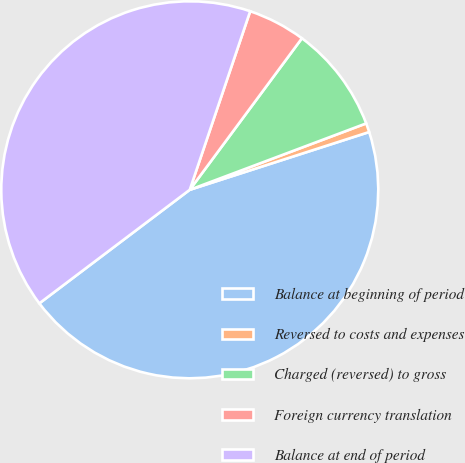<chart> <loc_0><loc_0><loc_500><loc_500><pie_chart><fcel>Balance at beginning of period<fcel>Reversed to costs and expenses<fcel>Charged (reversed) to gross<fcel>Foreign currency translation<fcel>Balance at end of period<nl><fcel>44.67%<fcel>0.77%<fcel>9.13%<fcel>4.95%<fcel>40.49%<nl></chart> 